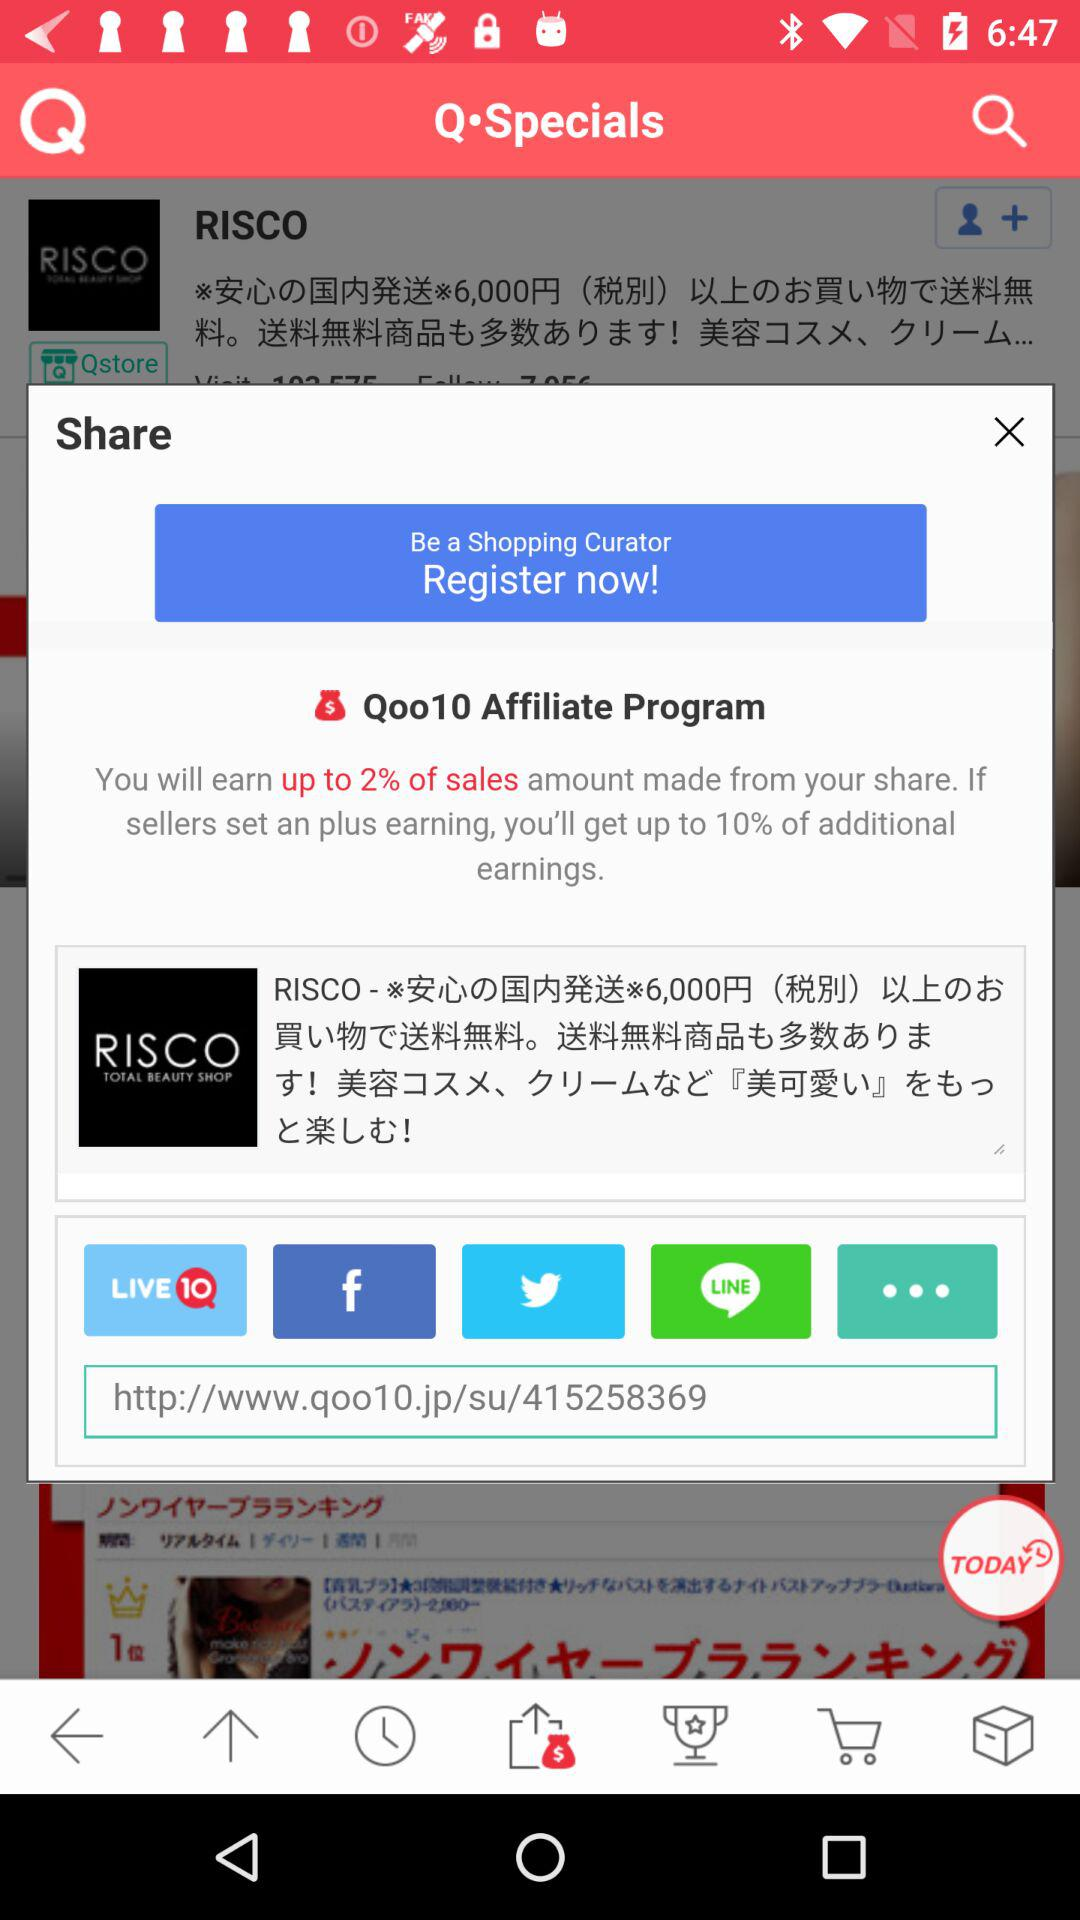When was the last purchase made?
When the provided information is insufficient, respond with <no answer>. <no answer> 